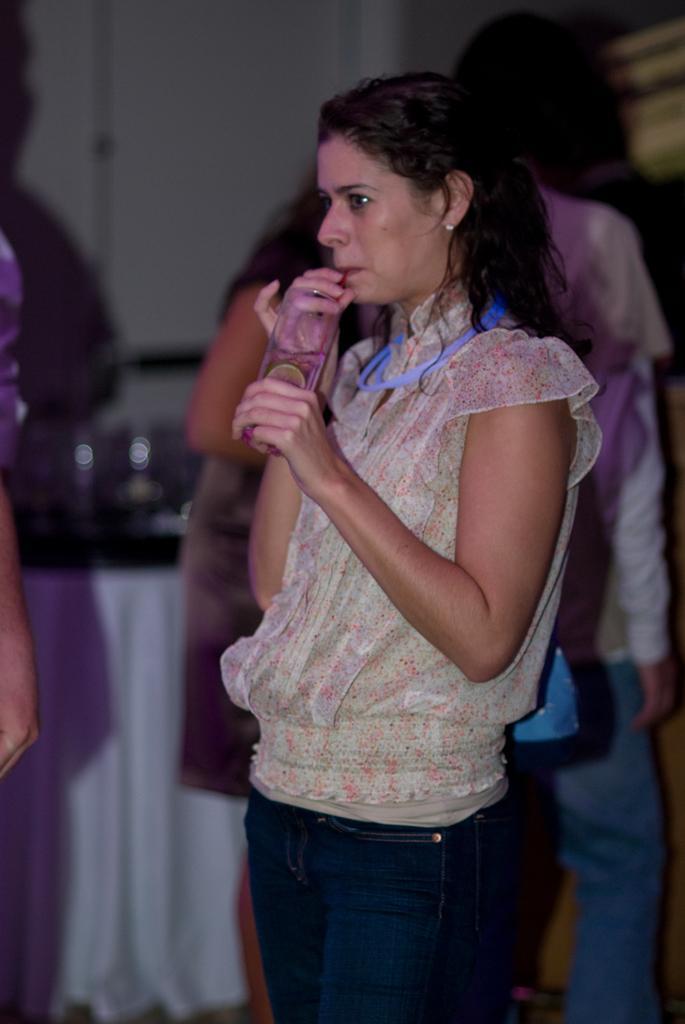Describe this image in one or two sentences. In this image I can see a woman wearing cream and blue colored dress is standing and holding a glass in her hand. I can see the blurry background in which I can see few persons and the wall. 